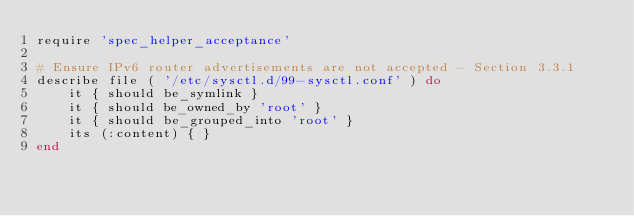Convert code to text. <code><loc_0><loc_0><loc_500><loc_500><_Ruby_>require 'spec_helper_acceptance'

# Ensure IPv6 router advertisements are not accepted - Section 3.3.1
describe file ( '/etc/sysctl.d/99-sysctl.conf' ) do
    it { should be_symlink }
    it { should be_owned_by 'root' }
    it { should be_grouped_into 'root' }
    its (:content) { }
end</code> 